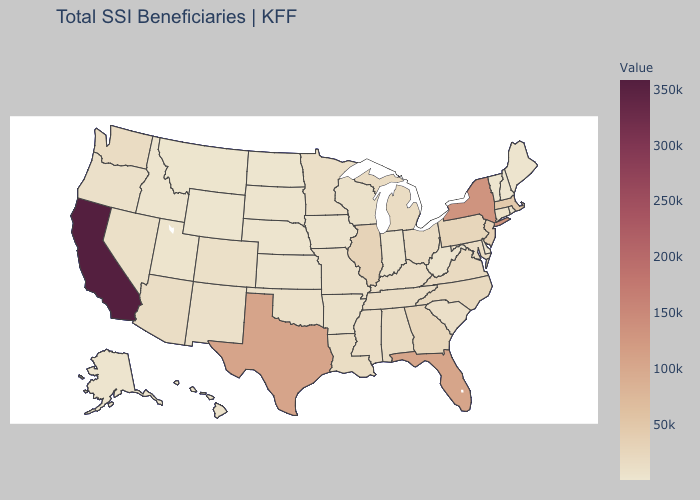Does Utah have the highest value in the West?
Keep it brief. No. Does the map have missing data?
Keep it brief. No. Does Ohio have the lowest value in the MidWest?
Write a very short answer. No. Which states hav the highest value in the South?
Be succinct. Texas. Among the states that border Mississippi , which have the lowest value?
Keep it brief. Arkansas. Does California have the highest value in the USA?
Keep it brief. Yes. Which states hav the highest value in the South?
Answer briefly. Texas. Is the legend a continuous bar?
Be succinct. Yes. Which states have the highest value in the USA?
Concise answer only. California. 